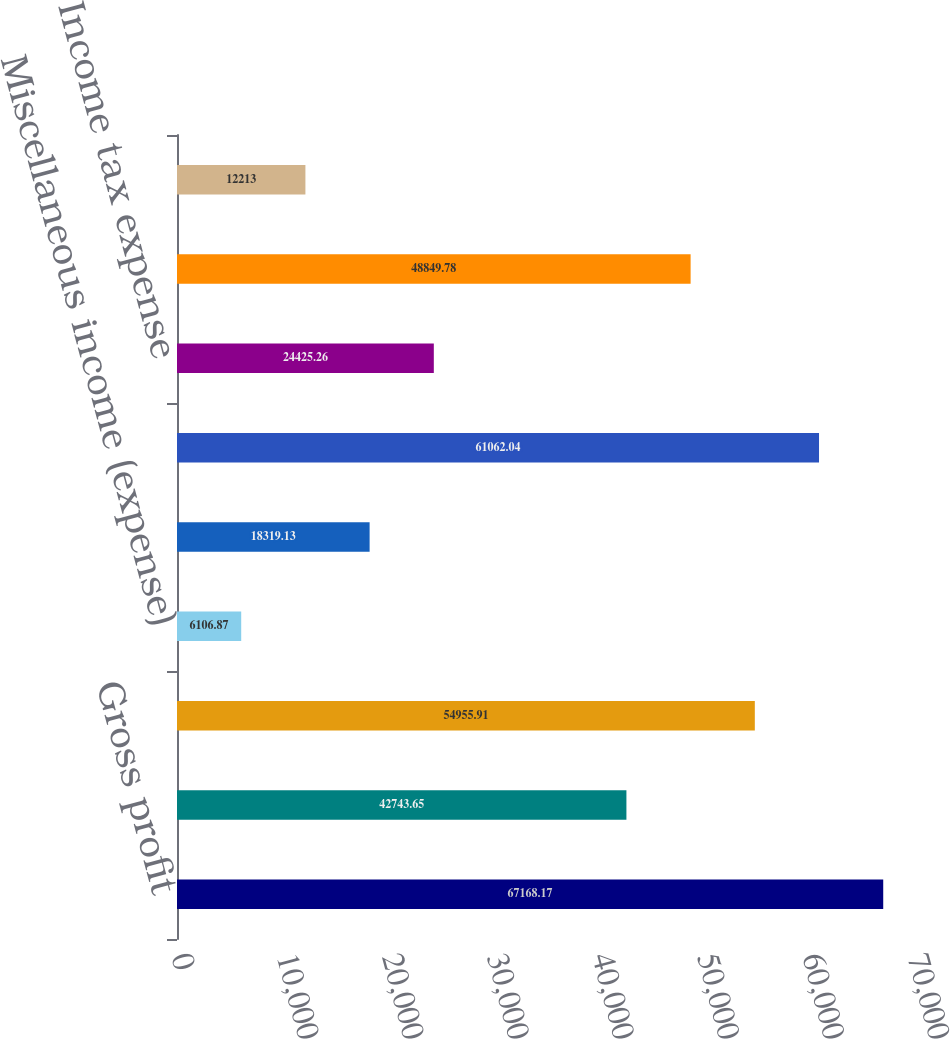Convert chart to OTSL. <chart><loc_0><loc_0><loc_500><loc_500><bar_chart><fcel>Gross profit<fcel>Operating expenses<fcel>Operating income<fcel>Miscellaneous income (expense)<fcel>Interest charges<fcel>Income before income taxes<fcel>Income tax expense<fcel>Net Income<fcel>Consolidated regulated<nl><fcel>67168.2<fcel>42743.7<fcel>54955.9<fcel>6106.87<fcel>18319.1<fcel>61062<fcel>24425.3<fcel>48849.8<fcel>12213<nl></chart> 